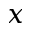Convert formula to latex. <formula><loc_0><loc_0><loc_500><loc_500>x</formula> 